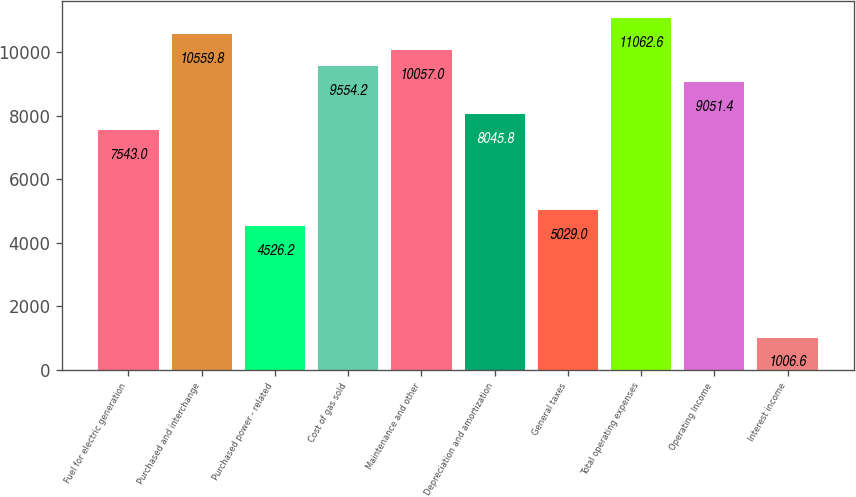Convert chart to OTSL. <chart><loc_0><loc_0><loc_500><loc_500><bar_chart><fcel>Fuel for electric generation<fcel>Purchased and interchange<fcel>Purchased power - related<fcel>Cost of gas sold<fcel>Maintenance and other<fcel>Depreciation and amortization<fcel>General taxes<fcel>Total operating expenses<fcel>Operating Income<fcel>Interest income<nl><fcel>7543<fcel>10559.8<fcel>4526.2<fcel>9554.2<fcel>10057<fcel>8045.8<fcel>5029<fcel>11062.6<fcel>9051.4<fcel>1006.6<nl></chart> 